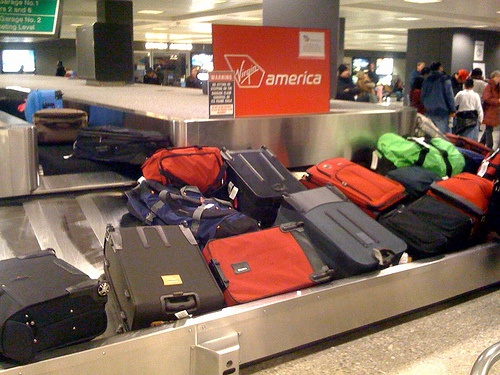Describe the objects in this image and their specific colors. I can see suitcase in darkgreen, black, and gray tones, suitcase in darkgreen, gray, black, and maroon tones, suitcase in darkgreen, red, gray, and black tones, suitcase in darkgreen, gray, black, and darkgray tones, and suitcase in darkgreen, black, gray, red, and brown tones in this image. 